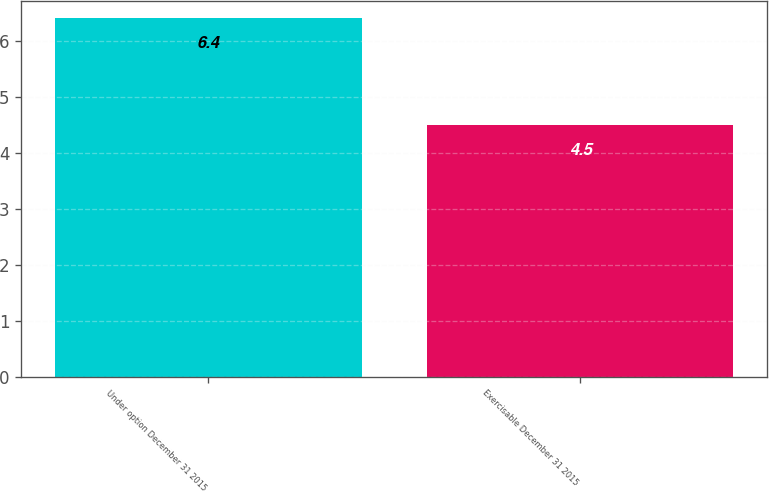Convert chart. <chart><loc_0><loc_0><loc_500><loc_500><bar_chart><fcel>Under option December 31 2015<fcel>Exercisable December 31 2015<nl><fcel>6.4<fcel>4.5<nl></chart> 